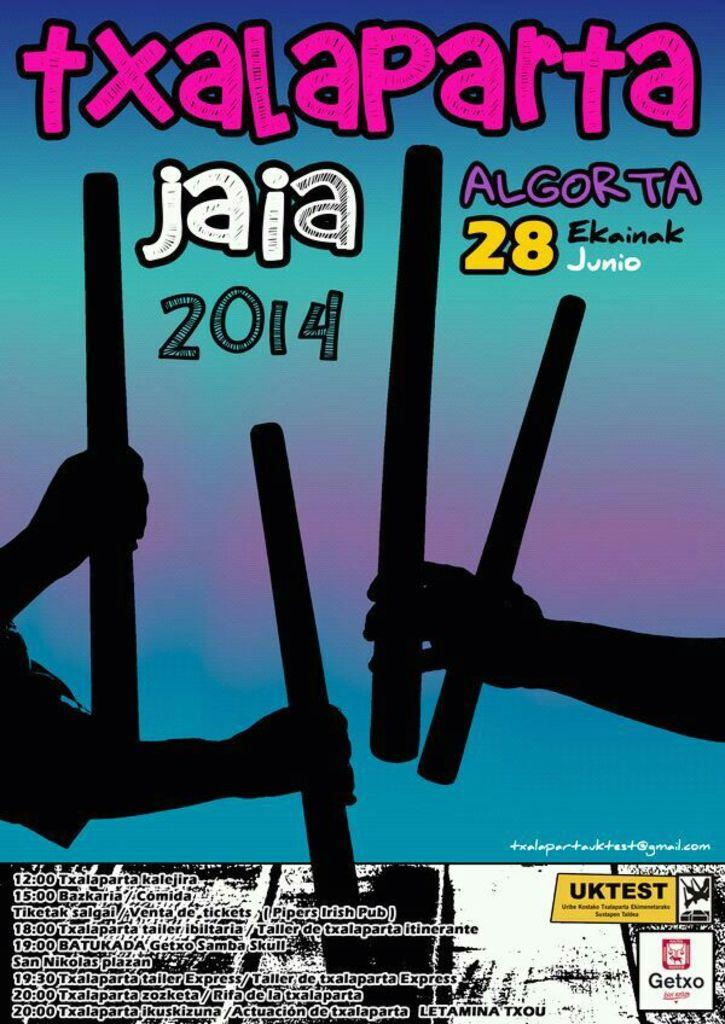Provide a one-sentence caption for the provided image. A poster in a foreign language featuring hands holding sticks from 2014. 